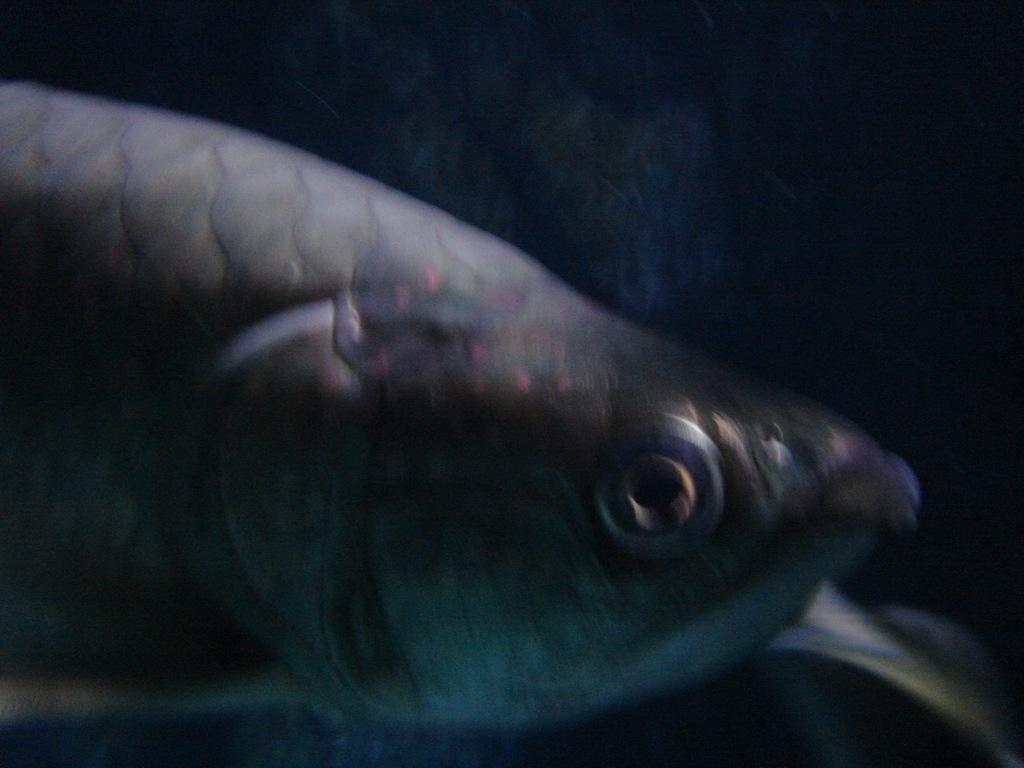What type of animal is present in the image? There is a fish in the image. How many beds can be seen in the image? There are no beds present in the image; it features a fish. What type of doll is holding the finger in the image? There is no doll or finger present in the image; it features a fish. 